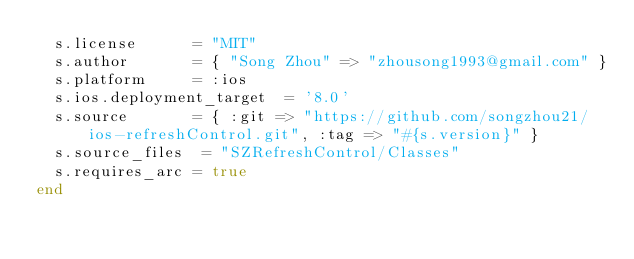Convert code to text. <code><loc_0><loc_0><loc_500><loc_500><_Ruby_>  s.license      = "MIT"
  s.author       = { "Song Zhou" => "zhousong1993@gmail.com" }
  s.platform     = :ios
  s.ios.deployment_target  = '8.0'
  s.source       = { :git => "https://github.com/songzhou21/ios-refreshControl.git", :tag => "#{s.version}" }
  s.source_files  = "SZRefreshControl/Classes"
  s.requires_arc = true
end
</code> 